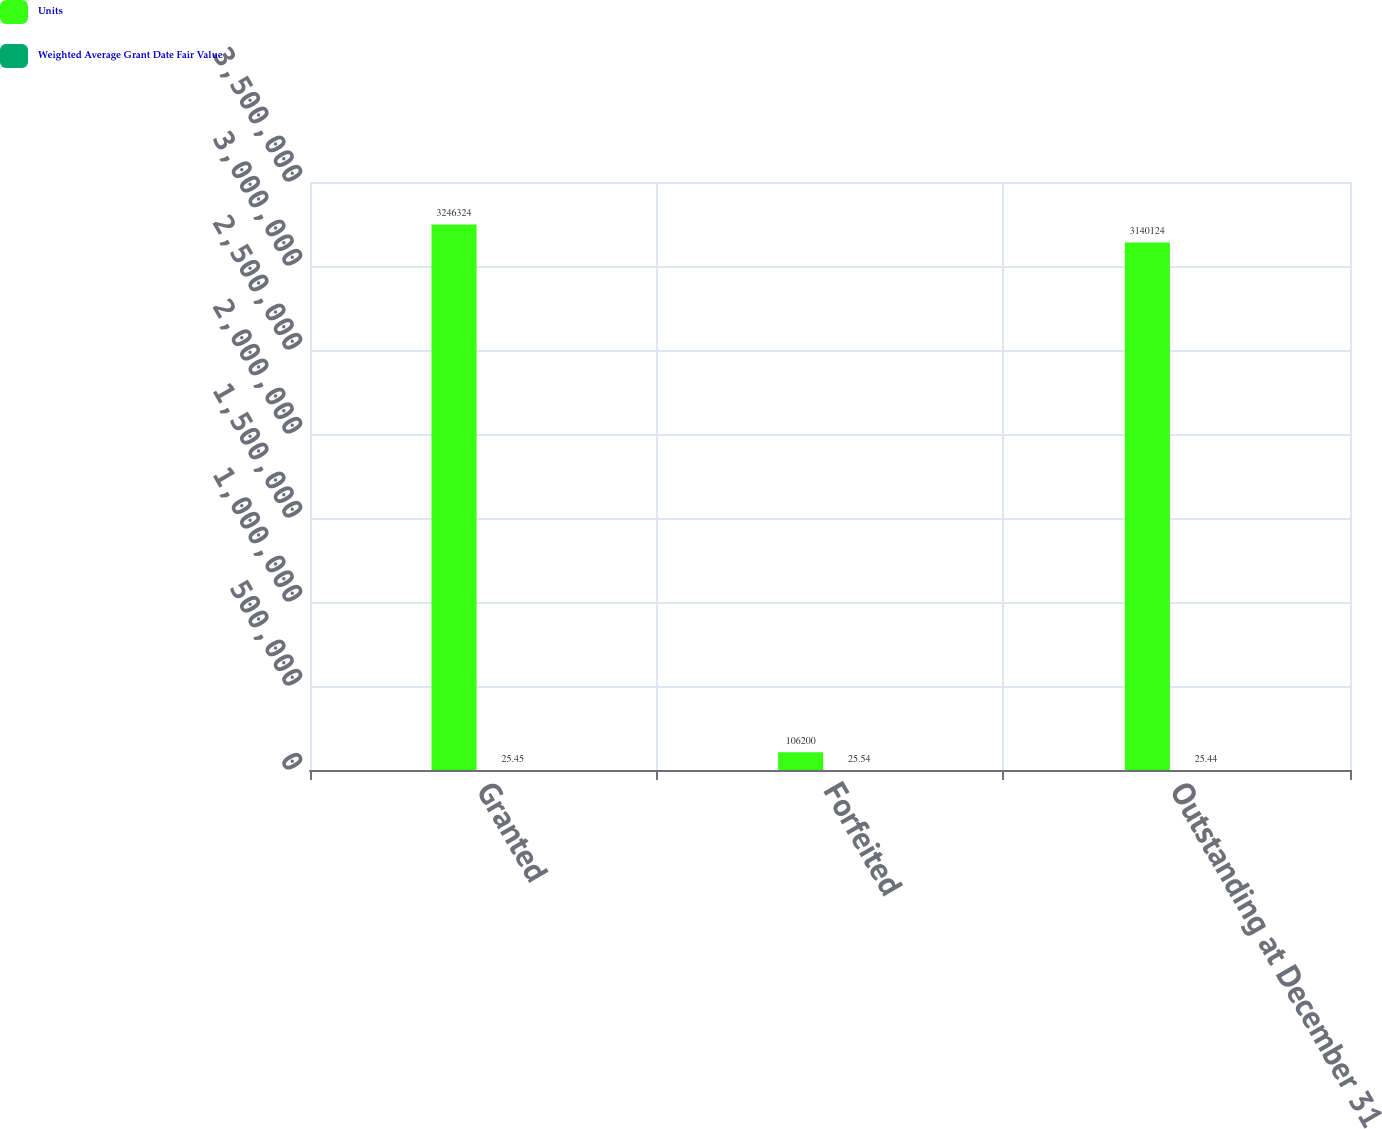Convert chart. <chart><loc_0><loc_0><loc_500><loc_500><stacked_bar_chart><ecel><fcel>Granted<fcel>Forfeited<fcel>Outstanding at December 31<nl><fcel>Units<fcel>3.24632e+06<fcel>106200<fcel>3.14012e+06<nl><fcel>Weighted Average Grant Date Fair Value<fcel>25.45<fcel>25.54<fcel>25.44<nl></chart> 